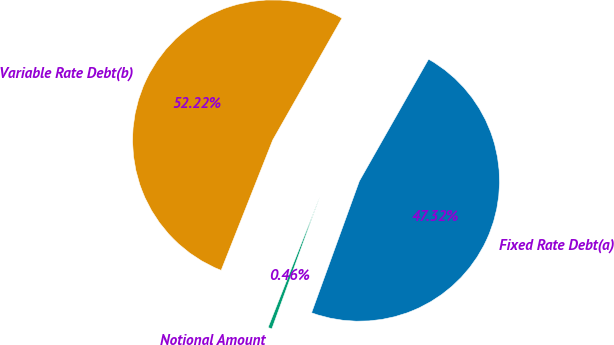Convert chart to OTSL. <chart><loc_0><loc_0><loc_500><loc_500><pie_chart><fcel>Fixed Rate Debt(a)<fcel>Variable Rate Debt(b)<fcel>Notional Amount<nl><fcel>47.32%<fcel>52.22%<fcel>0.46%<nl></chart> 